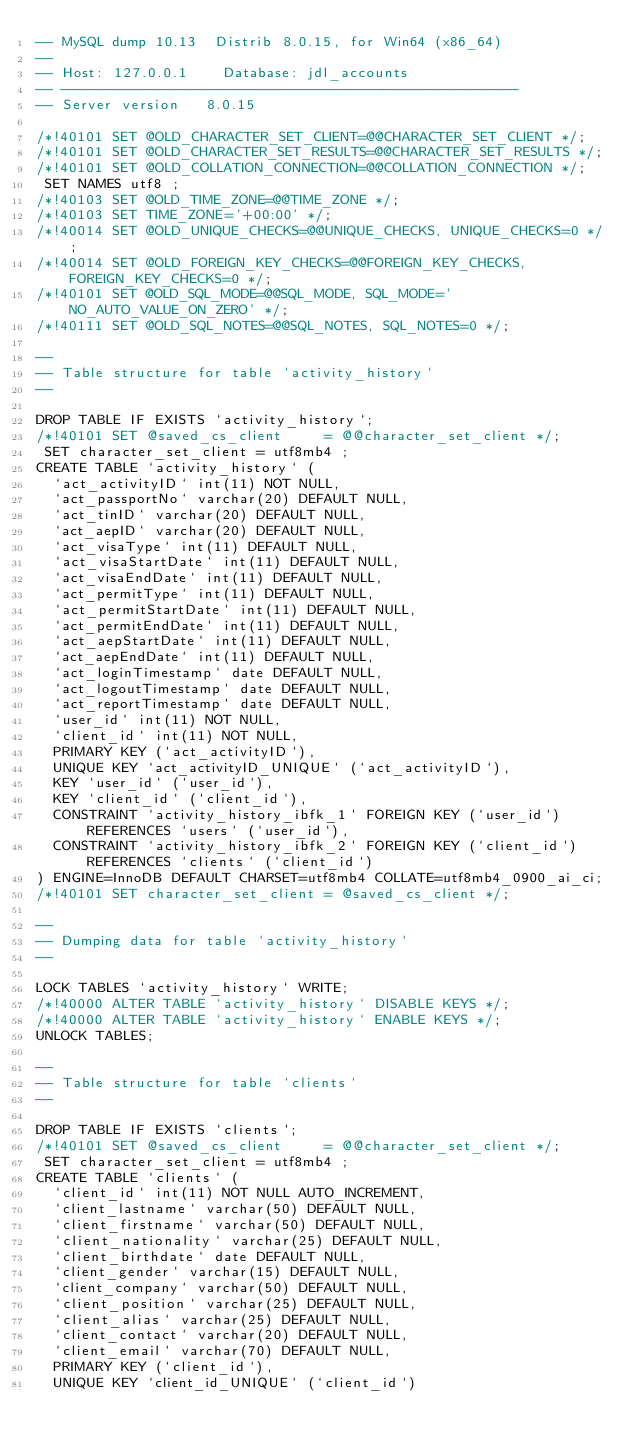Convert code to text. <code><loc_0><loc_0><loc_500><loc_500><_SQL_>-- MySQL dump 10.13  Distrib 8.0.15, for Win64 (x86_64)
--
-- Host: 127.0.0.1    Database: jdl_accounts
-- ------------------------------------------------------
-- Server version	8.0.15

/*!40101 SET @OLD_CHARACTER_SET_CLIENT=@@CHARACTER_SET_CLIENT */;
/*!40101 SET @OLD_CHARACTER_SET_RESULTS=@@CHARACTER_SET_RESULTS */;
/*!40101 SET @OLD_COLLATION_CONNECTION=@@COLLATION_CONNECTION */;
 SET NAMES utf8 ;
/*!40103 SET @OLD_TIME_ZONE=@@TIME_ZONE */;
/*!40103 SET TIME_ZONE='+00:00' */;
/*!40014 SET @OLD_UNIQUE_CHECKS=@@UNIQUE_CHECKS, UNIQUE_CHECKS=0 */;
/*!40014 SET @OLD_FOREIGN_KEY_CHECKS=@@FOREIGN_KEY_CHECKS, FOREIGN_KEY_CHECKS=0 */;
/*!40101 SET @OLD_SQL_MODE=@@SQL_MODE, SQL_MODE='NO_AUTO_VALUE_ON_ZERO' */;
/*!40111 SET @OLD_SQL_NOTES=@@SQL_NOTES, SQL_NOTES=0 */;

--
-- Table structure for table `activity_history`
--

DROP TABLE IF EXISTS `activity_history`;
/*!40101 SET @saved_cs_client     = @@character_set_client */;
 SET character_set_client = utf8mb4 ;
CREATE TABLE `activity_history` (
  `act_activityID` int(11) NOT NULL,
  `act_passportNo` varchar(20) DEFAULT NULL,
  `act_tinID` varchar(20) DEFAULT NULL,
  `act_aepID` varchar(20) DEFAULT NULL,
  `act_visaType` int(11) DEFAULT NULL,
  `act_visaStartDate` int(11) DEFAULT NULL,
  `act_visaEndDate` int(11) DEFAULT NULL,
  `act_permitType` int(11) DEFAULT NULL,
  `act_permitStartDate` int(11) DEFAULT NULL,
  `act_permitEndDate` int(11) DEFAULT NULL,
  `act_aepStartDate` int(11) DEFAULT NULL,
  `act_aepEndDate` int(11) DEFAULT NULL,
  `act_loginTimestamp` date DEFAULT NULL,
  `act_logoutTimestamp` date DEFAULT NULL,
  `act_reportTimestamp` date DEFAULT NULL,
  `user_id` int(11) NOT NULL,
  `client_id` int(11) NOT NULL,
  PRIMARY KEY (`act_activityID`),
  UNIQUE KEY `act_activityID_UNIQUE` (`act_activityID`),
  KEY `user_id` (`user_id`),
  KEY `client_id` (`client_id`),
  CONSTRAINT `activity_history_ibfk_1` FOREIGN KEY (`user_id`) REFERENCES `users` (`user_id`),
  CONSTRAINT `activity_history_ibfk_2` FOREIGN KEY (`client_id`) REFERENCES `clients` (`client_id`)
) ENGINE=InnoDB DEFAULT CHARSET=utf8mb4 COLLATE=utf8mb4_0900_ai_ci;
/*!40101 SET character_set_client = @saved_cs_client */;

--
-- Dumping data for table `activity_history`
--

LOCK TABLES `activity_history` WRITE;
/*!40000 ALTER TABLE `activity_history` DISABLE KEYS */;
/*!40000 ALTER TABLE `activity_history` ENABLE KEYS */;
UNLOCK TABLES;

--
-- Table structure for table `clients`
--

DROP TABLE IF EXISTS `clients`;
/*!40101 SET @saved_cs_client     = @@character_set_client */;
 SET character_set_client = utf8mb4 ;
CREATE TABLE `clients` (
  `client_id` int(11) NOT NULL AUTO_INCREMENT,
  `client_lastname` varchar(50) DEFAULT NULL,
  `client_firstname` varchar(50) DEFAULT NULL,
  `client_nationality` varchar(25) DEFAULT NULL,
  `client_birthdate` date DEFAULT NULL,
  `client_gender` varchar(15) DEFAULT NULL,
  `client_company` varchar(50) DEFAULT NULL,
  `client_position` varchar(25) DEFAULT NULL,
  `client_alias` varchar(25) DEFAULT NULL,
  `client_contact` varchar(20) DEFAULT NULL,
  `client_email` varchar(70) DEFAULT NULL,
  PRIMARY KEY (`client_id`),
  UNIQUE KEY `client_id_UNIQUE` (`client_id`)</code> 